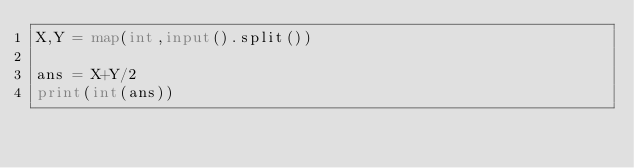<code> <loc_0><loc_0><loc_500><loc_500><_Python_>X,Y = map(int,input().split())

ans = X+Y/2
print(int(ans))
</code> 